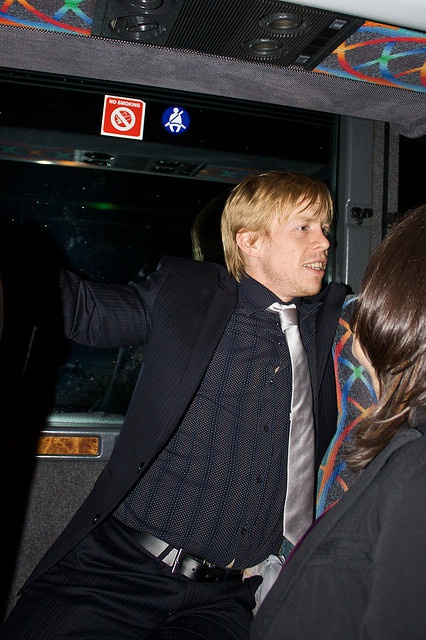Describe the objects in this image and their specific colors. I can see people in black, gray, and tan tones, people in black, gray, and maroon tones, and tie in black, gray, darkgray, and lightgray tones in this image. 